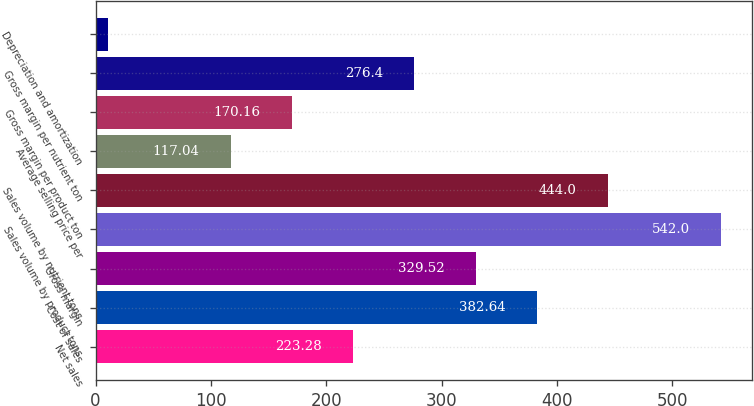Convert chart to OTSL. <chart><loc_0><loc_0><loc_500><loc_500><bar_chart><fcel>Net sales<fcel>Cost of sales<fcel>Gross margin<fcel>Sales volume by product tons<fcel>Sales volume by nutrient tons<fcel>Average selling price per<fcel>Gross margin per product ton<fcel>Gross margin per nutrient ton<fcel>Depreciation and amortization<nl><fcel>223.28<fcel>382.64<fcel>329.52<fcel>542<fcel>444<fcel>117.04<fcel>170.16<fcel>276.4<fcel>10.8<nl></chart> 